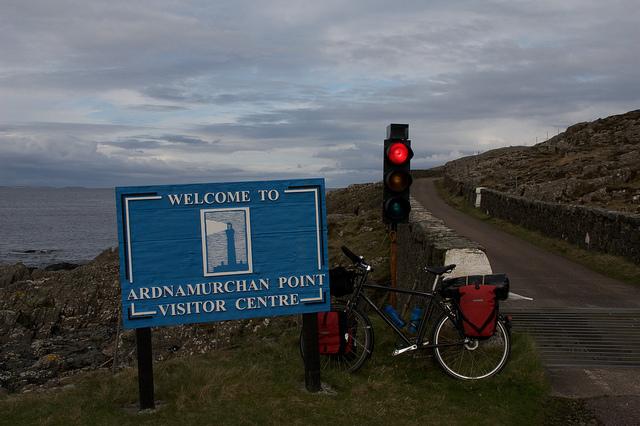What is blue on the bicycle?
Concise answer only. Water bottles. What color is the sign?
Concise answer only. Blue. What color is the traffic light?
Write a very short answer. Red. 